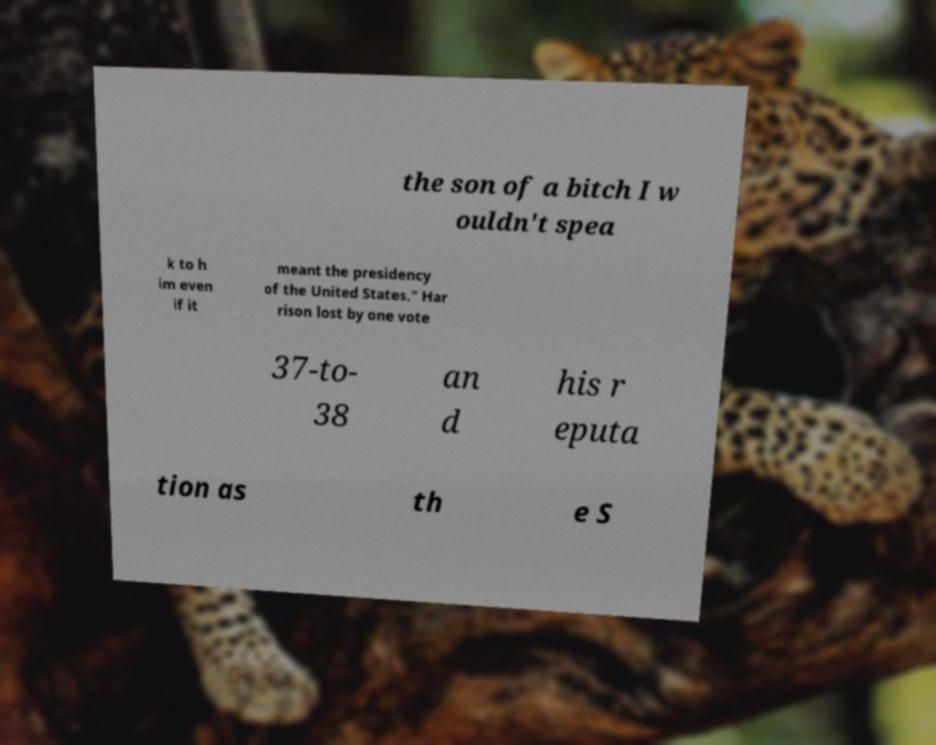Can you read and provide the text displayed in the image?This photo seems to have some interesting text. Can you extract and type it out for me? the son of a bitch I w ouldn't spea k to h im even if it meant the presidency of the United States." Har rison lost by one vote 37-to- 38 an d his r eputa tion as th e S 